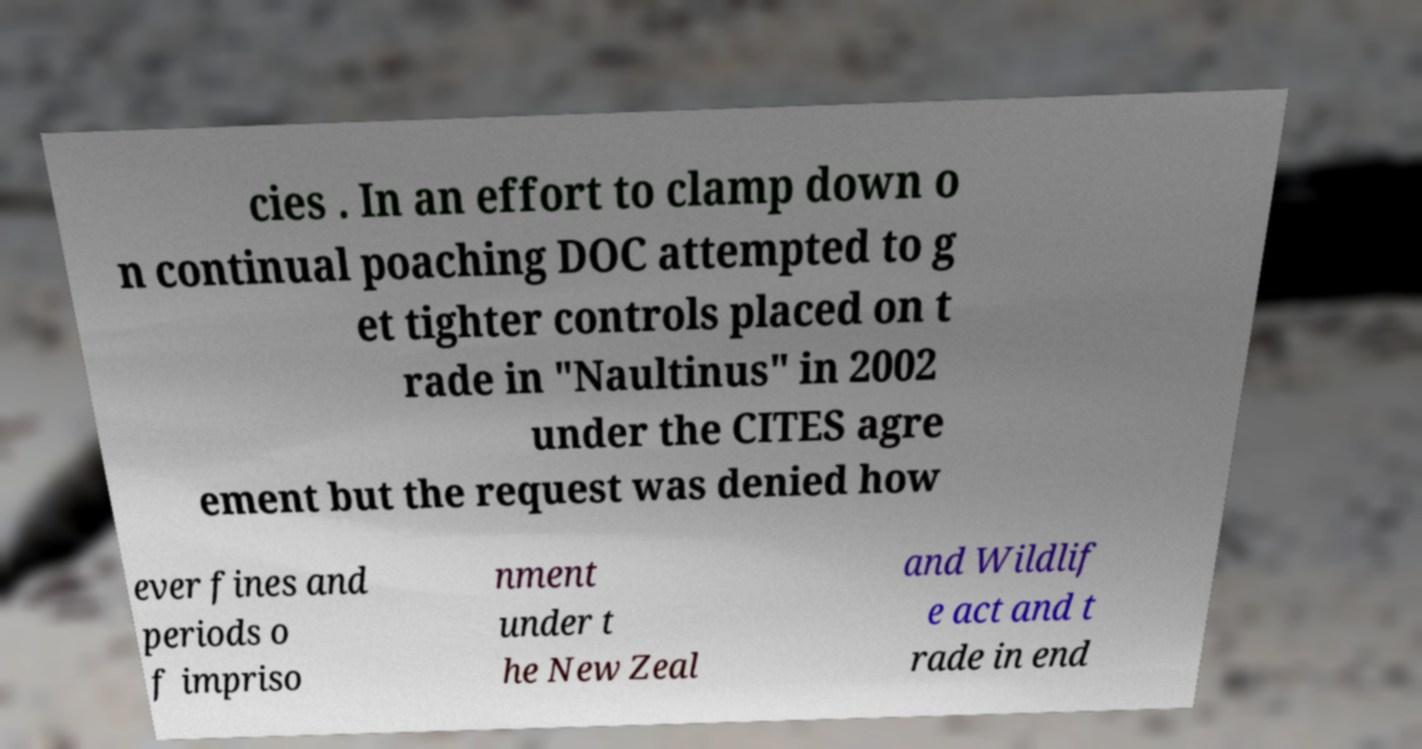What messages or text are displayed in this image? I need them in a readable, typed format. cies . In an effort to clamp down o n continual poaching DOC attempted to g et tighter controls placed on t rade in "Naultinus" in 2002 under the CITES agre ement but the request was denied how ever fines and periods o f impriso nment under t he New Zeal and Wildlif e act and t rade in end 